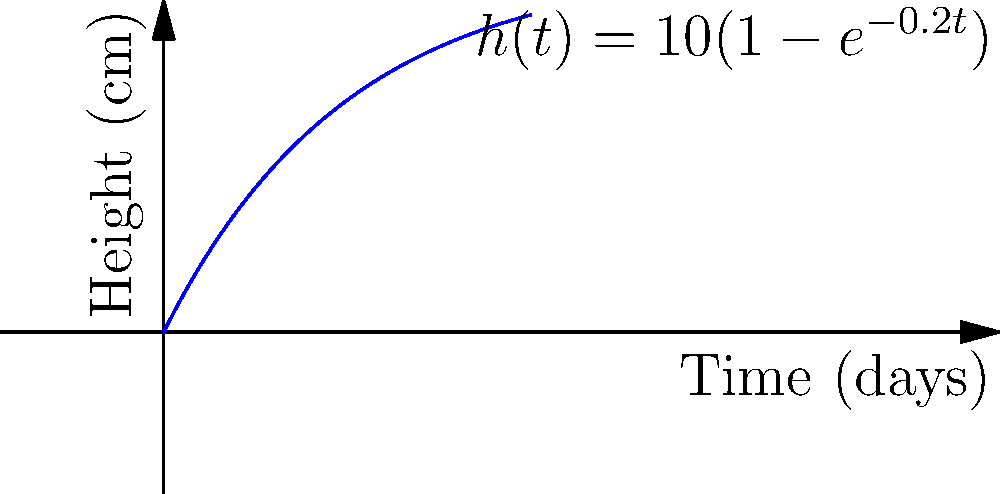In a magical garden, a special plant grows according to the function $h(t)=10(1-e^{-0.2t})$, where $h$ is the height in centimeters and $t$ is the time in days. What is the instantaneous rate of change of the plant's height after 5 days? Let's approach this step-by-step:

1) The rate of change of height with respect to time is given by the derivative of $h(t)$.

2) To find $\frac{dh}{dt}$, we use the chain rule:
   
   $\frac{dh}{dt} = 10 \cdot \frac{d}{dt}(1-e^{-0.2t})$
   $= 10 \cdot (-1) \cdot \frac{d}{dt}(e^{-0.2t})$
   $= 10 \cdot (-1) \cdot e^{-0.2t} \cdot (-0.2)$
   $= 2e^{-0.2t}$

3) Now we have the general formula for the rate of change at any time $t$.

4) To find the rate of change at $t=5$, we substitute this value:

   Rate at $t=5$ = $2e^{-0.2(5)}$ = $2e^{-1}$ cm/day

5) Using a calculator (or remembering that $e^{-1} \approx 0.368$):

   $2e^{-1} \approx 2(0.368) \approx 0.736$ cm/day

Therefore, after 5 days, the plant is growing at a rate of approximately 0.736 cm per day.
Answer: $0.736$ cm/day 